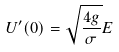<formula> <loc_0><loc_0><loc_500><loc_500>U ^ { \prime } ( 0 ) = \sqrt { \frac { 4 g } { \sigma } } E</formula> 